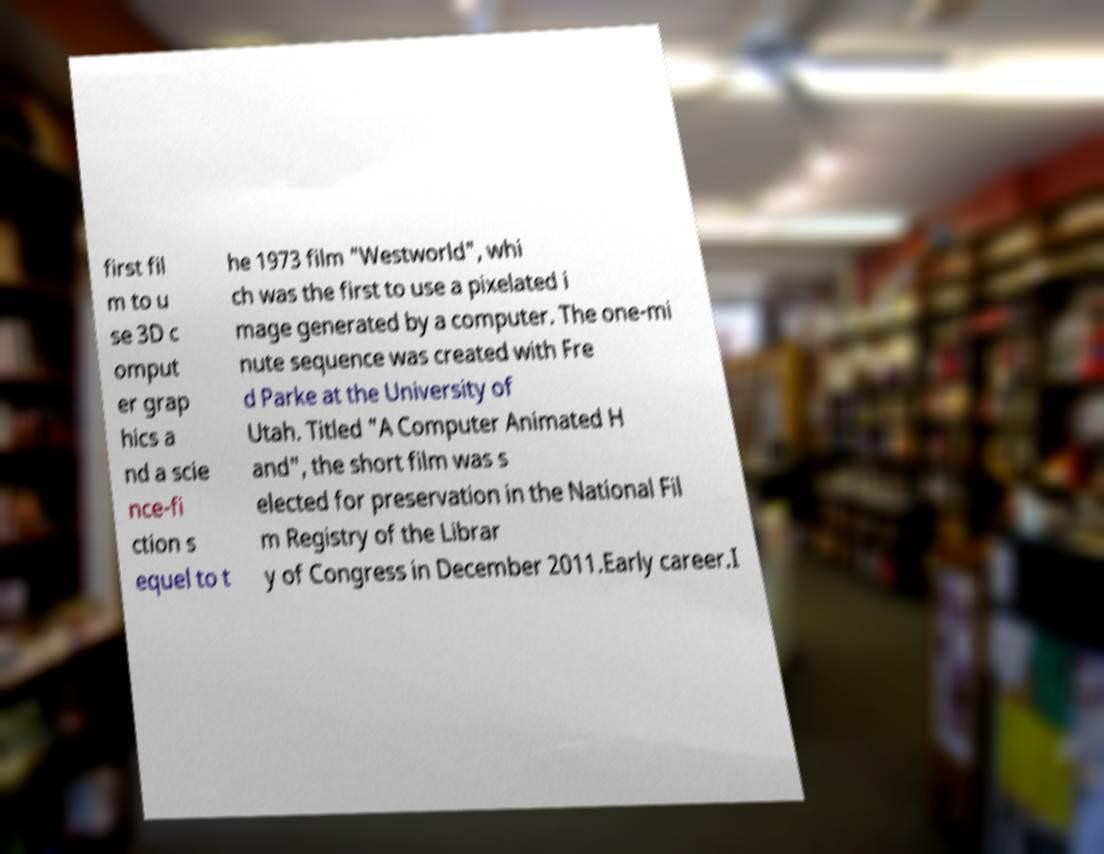Could you assist in decoding the text presented in this image and type it out clearly? first fil m to u se 3D c omput er grap hics a nd a scie nce-fi ction s equel to t he 1973 film "Westworld", whi ch was the first to use a pixelated i mage generated by a computer. The one-mi nute sequence was created with Fre d Parke at the University of Utah. Titled "A Computer Animated H and", the short film was s elected for preservation in the National Fil m Registry of the Librar y of Congress in December 2011.Early career.I 